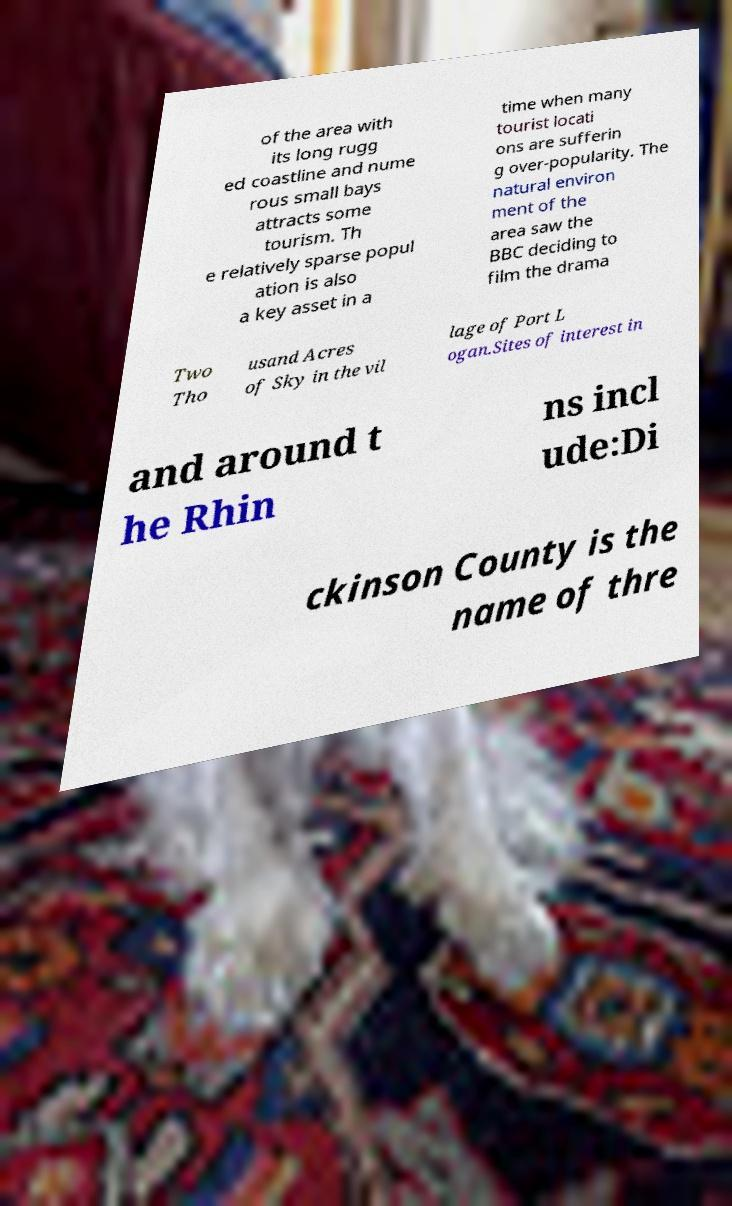What messages or text are displayed in this image? I need them in a readable, typed format. of the area with its long rugg ed coastline and nume rous small bays attracts some tourism. Th e relatively sparse popul ation is also a key asset in a time when many tourist locati ons are sufferin g over-popularity. The natural environ ment of the area saw the BBC deciding to film the drama Two Tho usand Acres of Sky in the vil lage of Port L ogan.Sites of interest in and around t he Rhin ns incl ude:Di ckinson County is the name of thre 